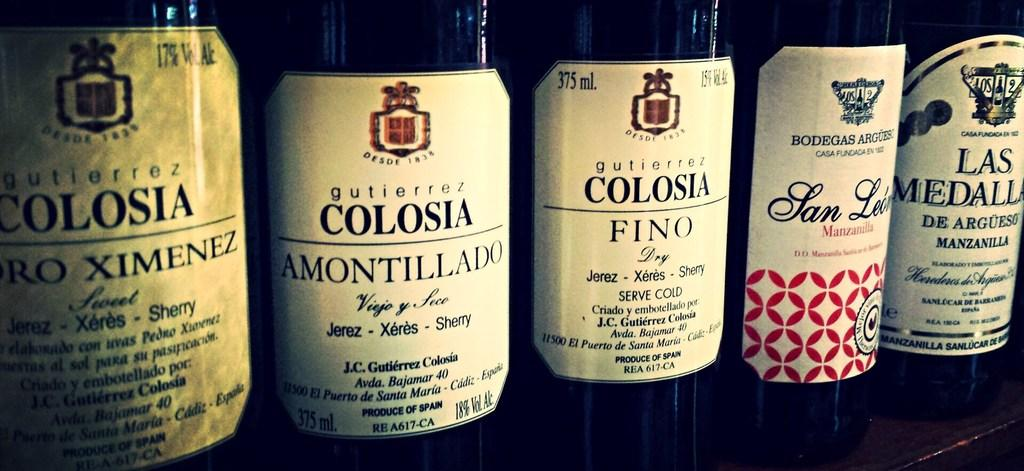<image>
Share a concise interpretation of the image provided. A row of wine bottles have varying labels including the far left bottle of Colosia. 